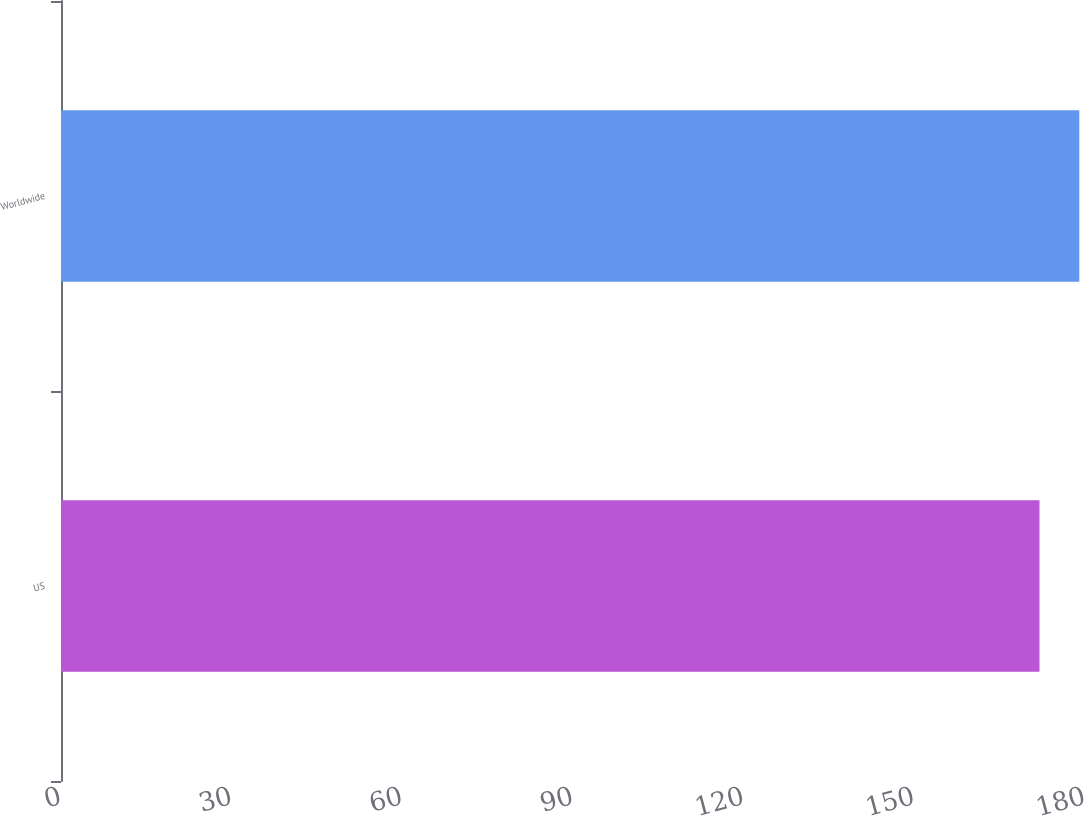Convert chart to OTSL. <chart><loc_0><loc_0><loc_500><loc_500><bar_chart><fcel>US<fcel>Worldwide<nl><fcel>172<fcel>179<nl></chart> 